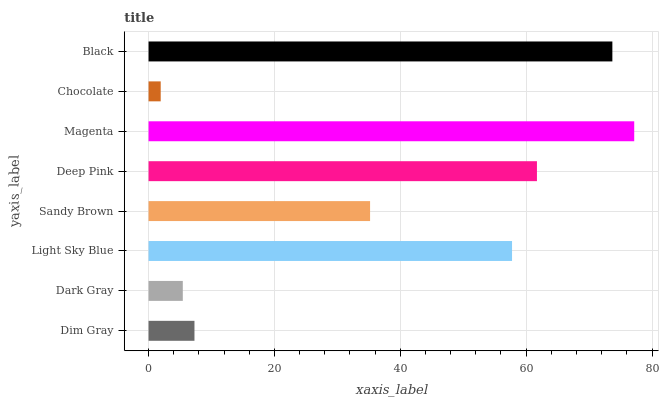Is Chocolate the minimum?
Answer yes or no. Yes. Is Magenta the maximum?
Answer yes or no. Yes. Is Dark Gray the minimum?
Answer yes or no. No. Is Dark Gray the maximum?
Answer yes or no. No. Is Dim Gray greater than Dark Gray?
Answer yes or no. Yes. Is Dark Gray less than Dim Gray?
Answer yes or no. Yes. Is Dark Gray greater than Dim Gray?
Answer yes or no. No. Is Dim Gray less than Dark Gray?
Answer yes or no. No. Is Light Sky Blue the high median?
Answer yes or no. Yes. Is Sandy Brown the low median?
Answer yes or no. Yes. Is Sandy Brown the high median?
Answer yes or no. No. Is Dark Gray the low median?
Answer yes or no. No. 